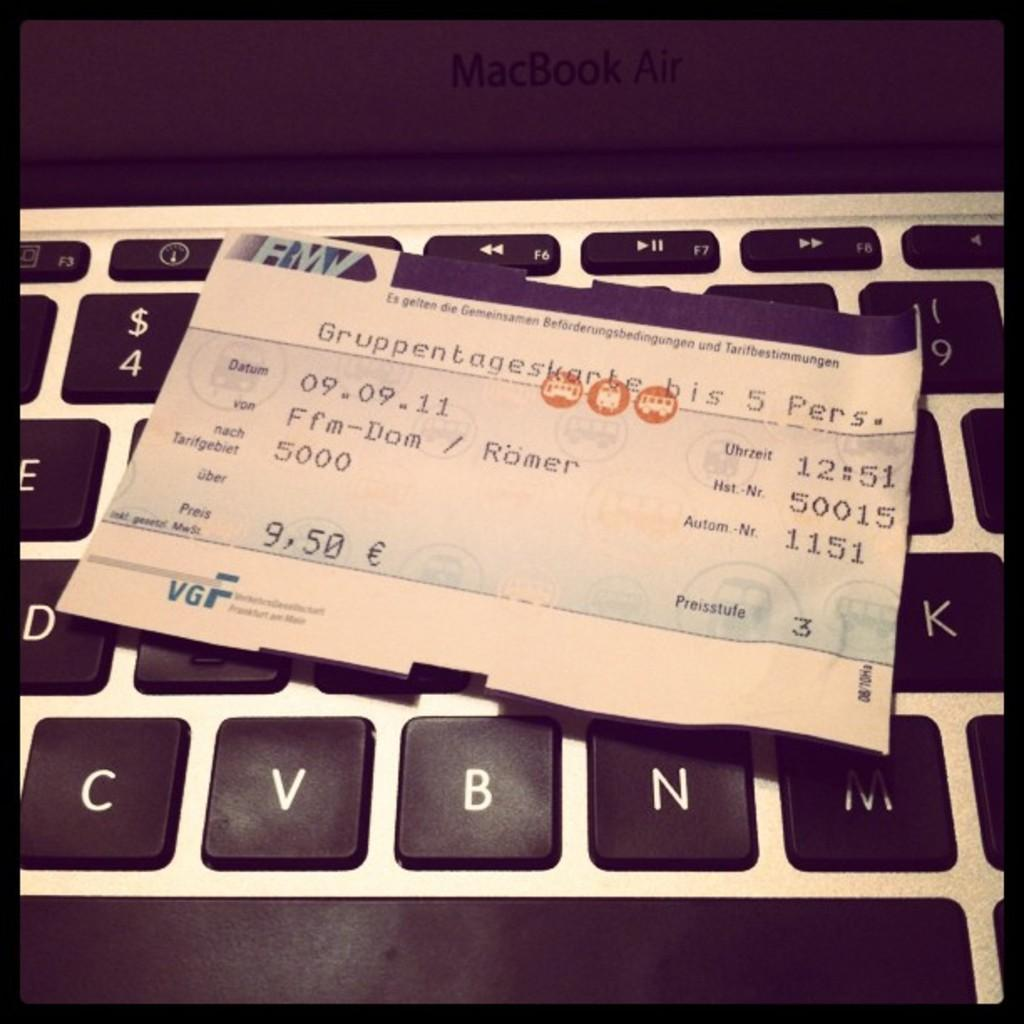<image>
Describe the image concisely. A nine and a half Euro check is laying on a keyboard. 